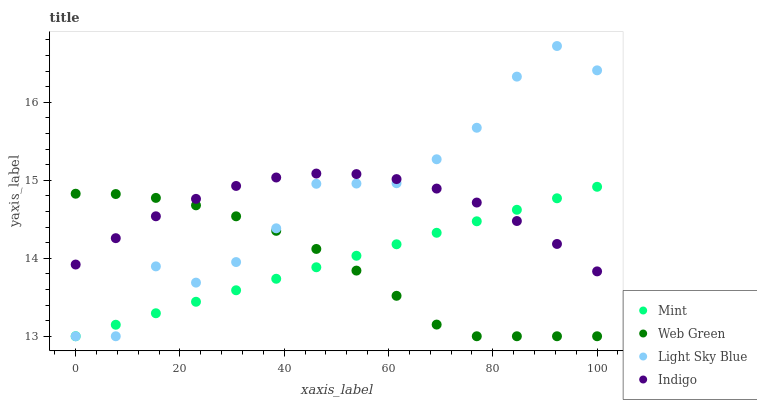Does Web Green have the minimum area under the curve?
Answer yes or no. Yes. Does Light Sky Blue have the maximum area under the curve?
Answer yes or no. Yes. Does Mint have the minimum area under the curve?
Answer yes or no. No. Does Mint have the maximum area under the curve?
Answer yes or no. No. Is Mint the smoothest?
Answer yes or no. Yes. Is Light Sky Blue the roughest?
Answer yes or no. Yes. Is Light Sky Blue the smoothest?
Answer yes or no. No. Is Mint the roughest?
Answer yes or no. No. Does Light Sky Blue have the lowest value?
Answer yes or no. Yes. Does Light Sky Blue have the highest value?
Answer yes or no. Yes. Does Mint have the highest value?
Answer yes or no. No. Does Indigo intersect Mint?
Answer yes or no. Yes. Is Indigo less than Mint?
Answer yes or no. No. Is Indigo greater than Mint?
Answer yes or no. No. 